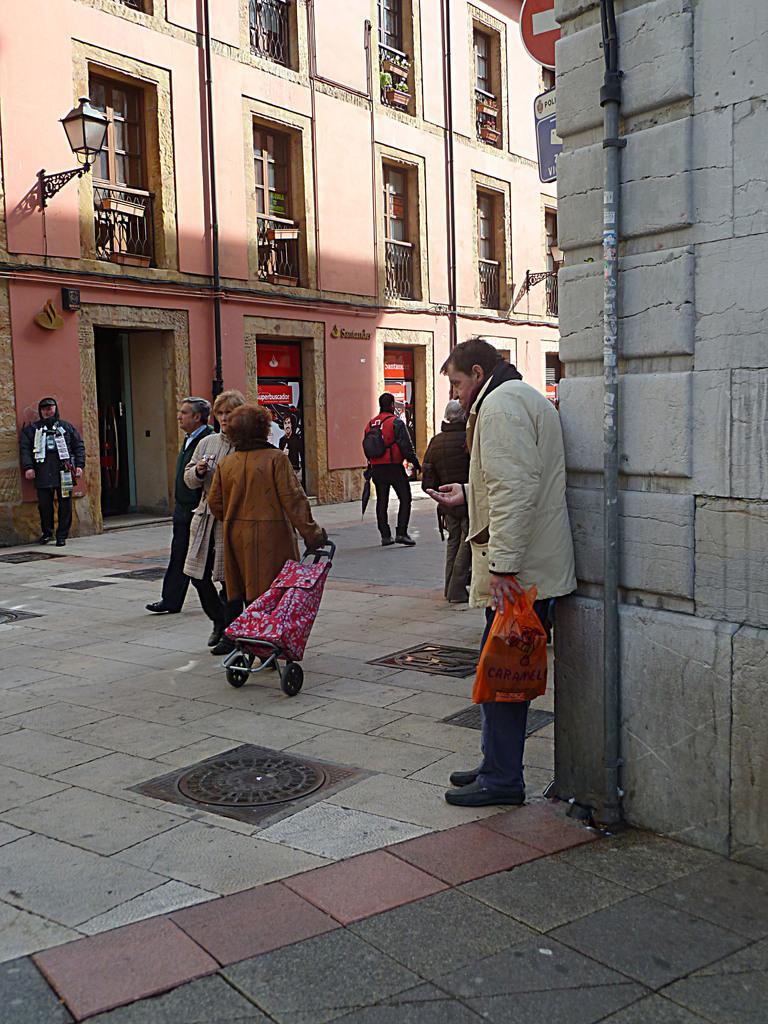How would you summarize this image in a sentence or two? Here in this picture we can see number of people standing and walking on the ground and the woman int he middle is carrying a baby stroller with her and beside them we can see a building with number of windows present over there and we can also see a lamp post present and in the front we can see a pipe present on the building. 